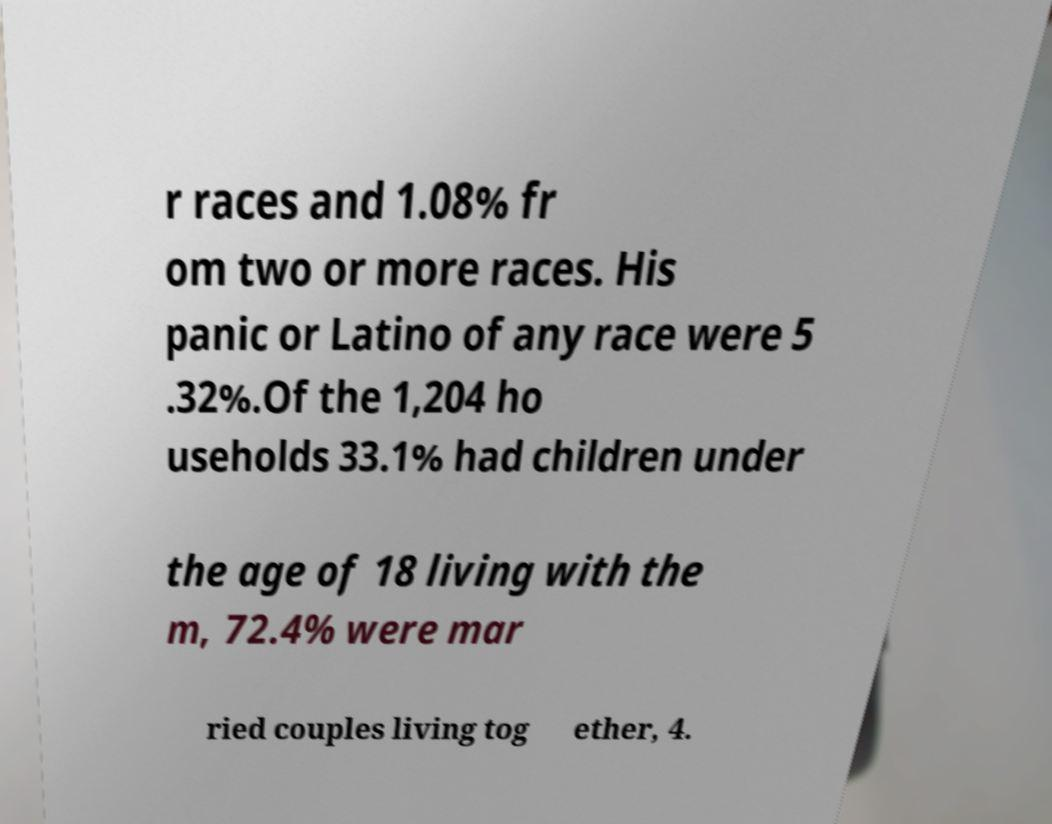Please identify and transcribe the text found in this image. r races and 1.08% fr om two or more races. His panic or Latino of any race were 5 .32%.Of the 1,204 ho useholds 33.1% had children under the age of 18 living with the m, 72.4% were mar ried couples living tog ether, 4. 